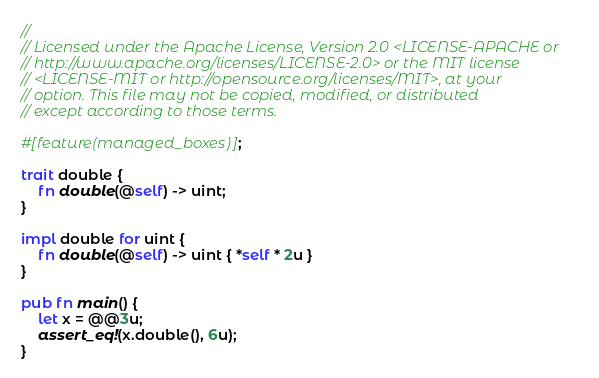Convert code to text. <code><loc_0><loc_0><loc_500><loc_500><_Rust_>//
// Licensed under the Apache License, Version 2.0 <LICENSE-APACHE or
// http://www.apache.org/licenses/LICENSE-2.0> or the MIT license
// <LICENSE-MIT or http://opensource.org/licenses/MIT>, at your
// option. This file may not be copied, modified, or distributed
// except according to those terms.

#[feature(managed_boxes)];

trait double {
    fn double(@self) -> uint;
}

impl double for uint {
    fn double(@self) -> uint { *self * 2u }
}

pub fn main() {
    let x = @@3u;
    assert_eq!(x.double(), 6u);
}
</code> 